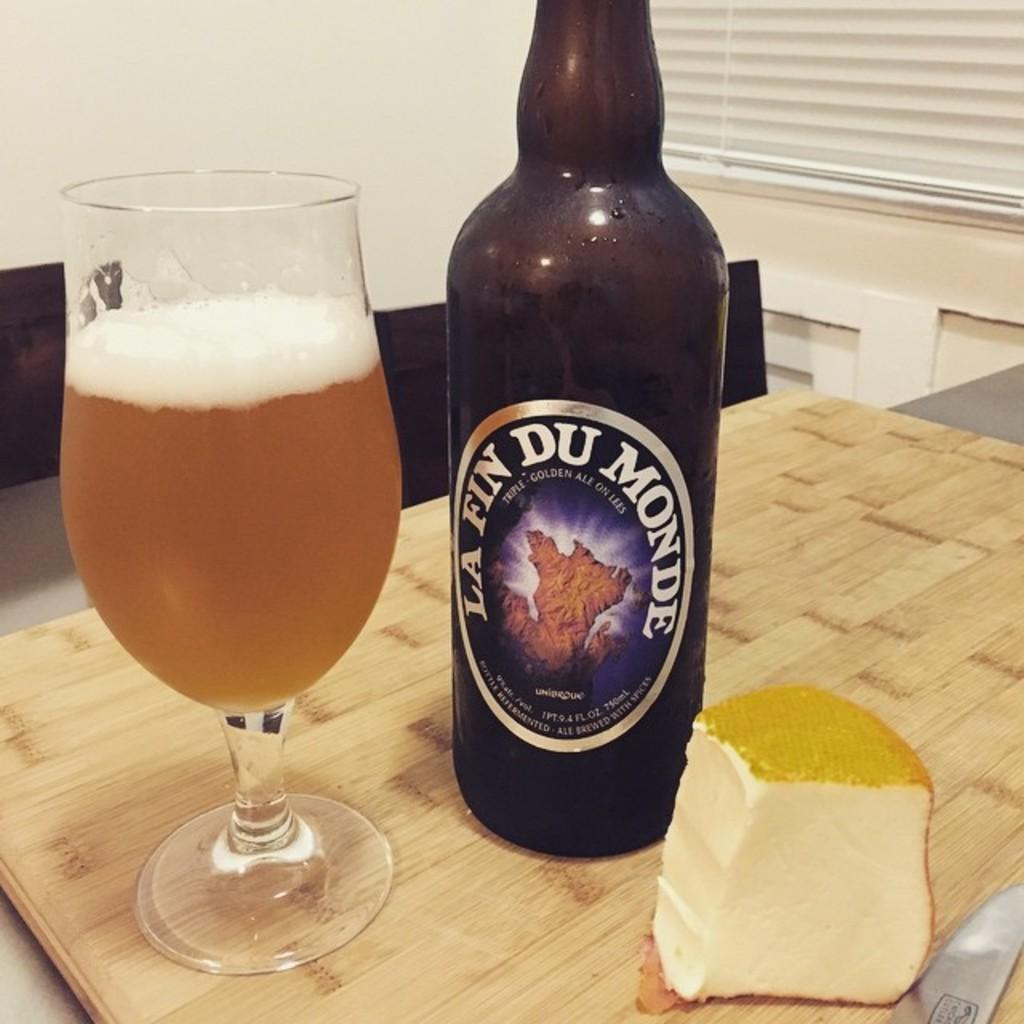<image>
Offer a succinct explanation of the picture presented. the word la fin du monde on the front of a bottle 